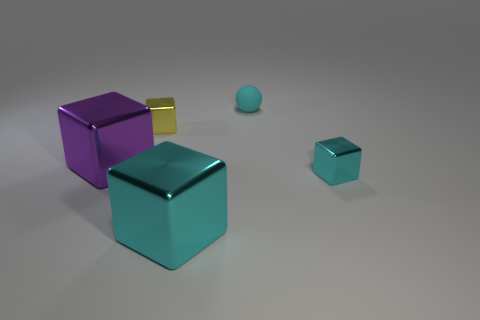Is there anything else that is the same material as the cyan sphere?
Give a very brief answer. No. There is a cyan metallic object that is in front of the cyan shiny cube that is right of the cyan matte sphere; how many cyan shiny things are in front of it?
Give a very brief answer. 0. How many metal blocks are left of the small yellow block and to the right of the tiny cyan rubber sphere?
Ensure brevity in your answer.  0. Is the number of tiny spheres that are behind the tiny cyan cube greater than the number of big blue cylinders?
Give a very brief answer. Yes. How many objects have the same size as the purple shiny block?
Ensure brevity in your answer.  1. How many big things are yellow blocks or cyan matte things?
Provide a succinct answer. 0. How many big cylinders are there?
Keep it short and to the point. 0. Are there an equal number of big cyan metallic objects that are behind the small matte sphere and objects that are in front of the big purple metallic thing?
Offer a terse response. No. Are there any small blocks left of the purple metallic cube?
Keep it short and to the point. No. There is a tiny metal object that is behind the purple object; what is its color?
Provide a short and direct response. Yellow. 